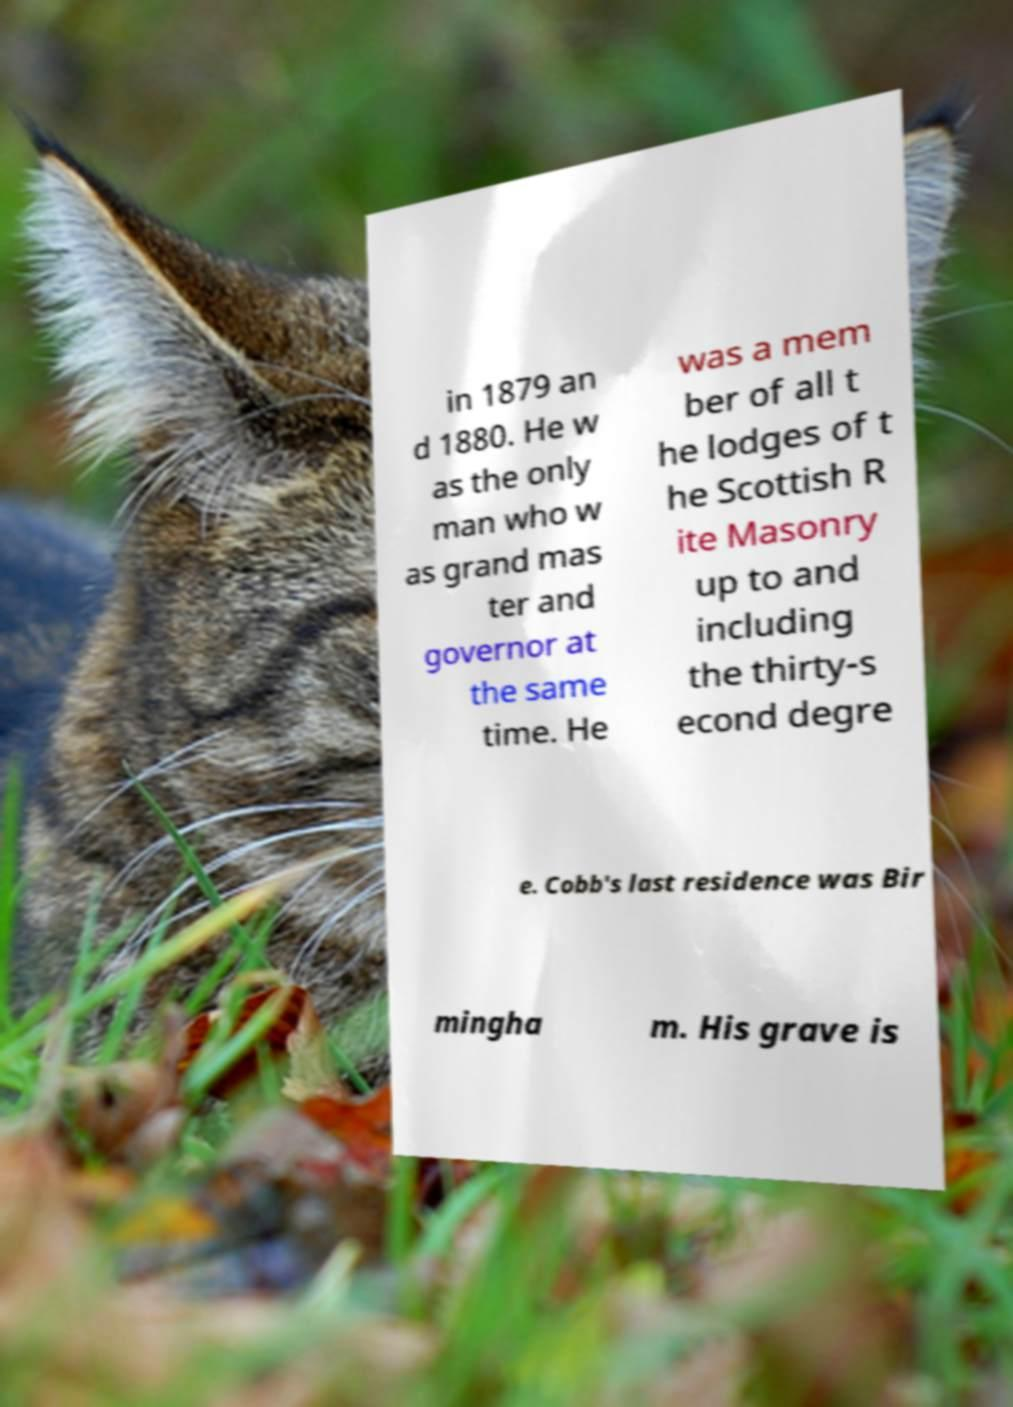Could you extract and type out the text from this image? in 1879 an d 1880. He w as the only man who w as grand mas ter and governor at the same time. He was a mem ber of all t he lodges of t he Scottish R ite Masonry up to and including the thirty-s econd degre e. Cobb's last residence was Bir mingha m. His grave is 